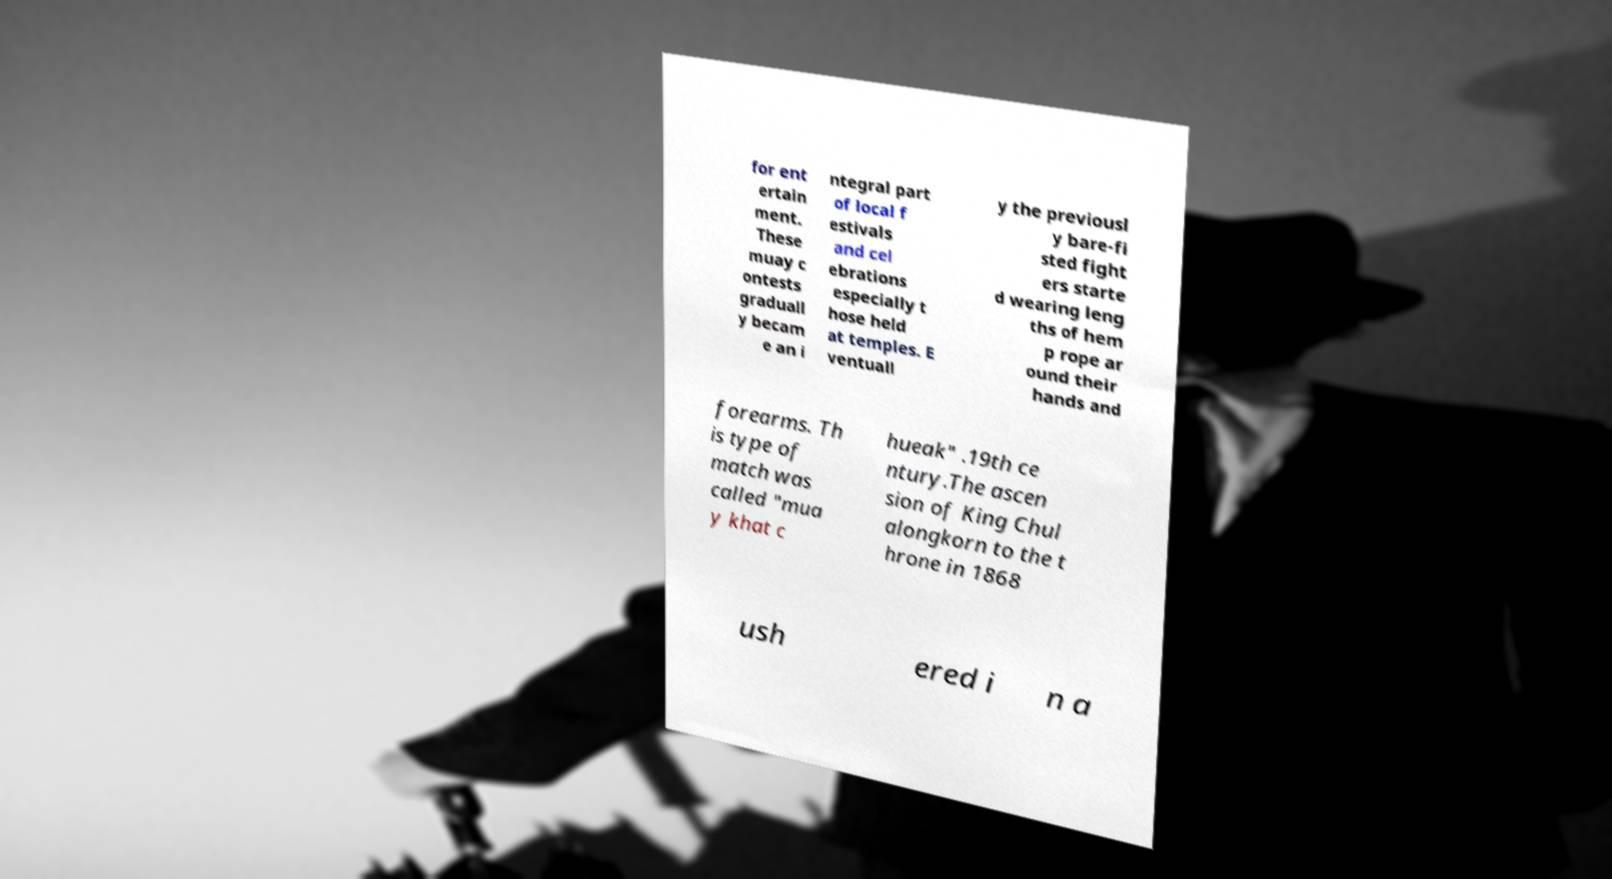What messages or text are displayed in this image? I need them in a readable, typed format. for ent ertain ment. These muay c ontests graduall y becam e an i ntegral part of local f estivals and cel ebrations especially t hose held at temples. E ventuall y the previousl y bare-fi sted fight ers starte d wearing leng ths of hem p rope ar ound their hands and forearms. Th is type of match was called "mua y khat c hueak" .19th ce ntury.The ascen sion of King Chul alongkorn to the t hrone in 1868 ush ered i n a 